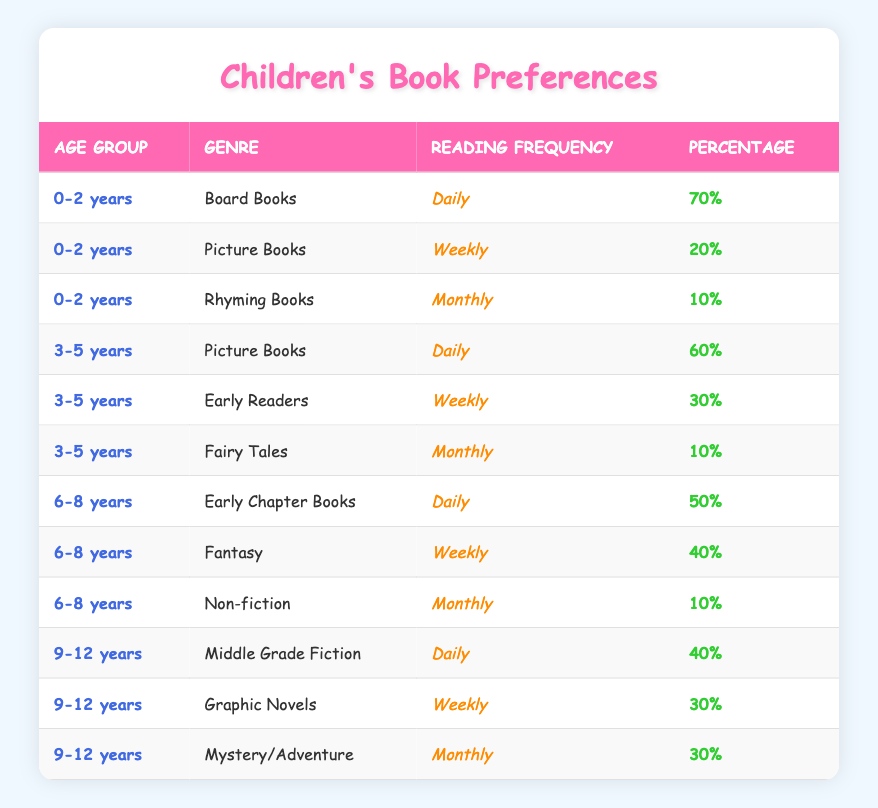What genre do children aged 0-2 years prefer to read daily? From the table, the genre preferred by children aged 0-2 years that has a daily reading frequency is 'Board Books', with a percentage of 70%.
Answer: Board Books What percentage of children aged 3-5 years read Fairy Tales monthly? Referring to the table, children aged 3-5 years read Fairy Tales monthly with a percentage of 10%.
Answer: 10% Is it true that more children aged 6-8 years prefer Fantasy books weekly than Early Chapter Books? Checking the percentages for children aged 6-8 years, 40% prefer Fantasy books weekly while 50% prefer Early Chapter Books daily. Therefore, the statement is false.
Answer: No What is the total percentage of daily readers among all age groups? To find the total percentage of daily readers, we look at the 'Daily' reading frequency for each age group: 70% (0-2) + 60% (3-5) + 50% (6-8) + 40% (9-12) = 220%. The total percentage of daily readers is therefore 220%.
Answer: 220% Which age group has the lowest percentage for monthly reading frequency? In the table, for monthly reading frequency, the percentages for each age group are: 10% (0-2 years for Rhyming Books), 10% (3-5 years for Fairy Tales), 10% (6-8 years for Non-fiction), and 30% (9-12 years for Mystery/Adventure). The lowest percentage is 10%.
Answer: 0-2 years, 3-5 years, 6-8 years What is the average percentage of reading frequency for children aged 9-12 years? The percentages for children aged 9-12 years are: 40% (Middle Grade Fiction), 30% (Graphic Novels), and 30% (Mystery/Adventure). To find the average, we sum these percentages: 40 + 30 + 30 = 100%, and then divide by 3 (the number of genres) which equals to 33.33%.
Answer: 33.33% 